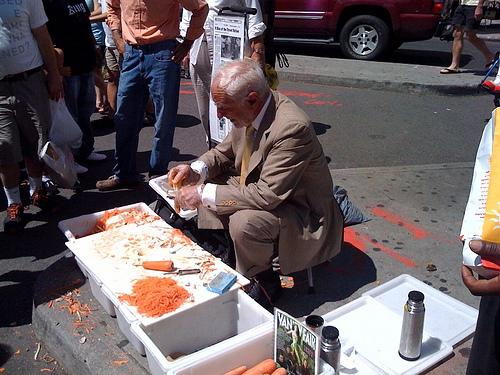What is the orange item?

Choices:
A) carrot
B) pumpkin pie
C) traffic cone
D) sticky note carrot 